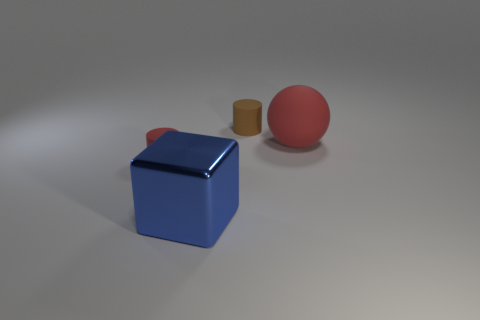Add 2 tiny brown objects. How many objects exist? 6 Subtract all brown cylinders. How many cylinders are left? 1 Subtract 1 balls. How many balls are left? 0 Subtract all blocks. How many objects are left? 3 Subtract all green cubes. Subtract all yellow cylinders. How many cubes are left? 1 Subtract all red objects. Subtract all tiny cylinders. How many objects are left? 0 Add 2 tiny matte objects. How many tiny matte objects are left? 4 Add 4 rubber cylinders. How many rubber cylinders exist? 6 Subtract 0 purple cubes. How many objects are left? 4 